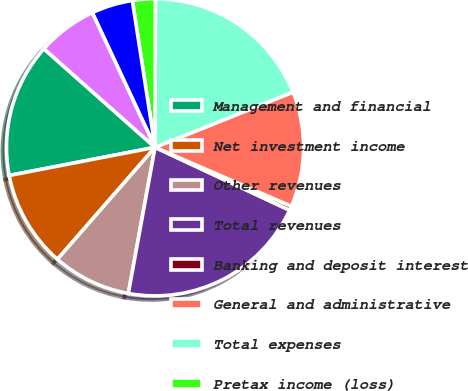Convert chart to OTSL. <chart><loc_0><loc_0><loc_500><loc_500><pie_chart><fcel>Management and financial<fcel>Net investment income<fcel>Other revenues<fcel>Total revenues<fcel>Banking and deposit interest<fcel>General and administrative<fcel>Total expenses<fcel>Pretax income (loss)<fcel>Net income (loss)<fcel>Net income (loss) attributable<nl><fcel>14.58%<fcel>10.55%<fcel>8.53%<fcel>20.92%<fcel>0.46%<fcel>12.56%<fcel>18.9%<fcel>2.48%<fcel>4.5%<fcel>6.51%<nl></chart> 